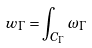<formula> <loc_0><loc_0><loc_500><loc_500>w _ { \Gamma } = \int _ { C _ { \Gamma } } \omega _ { \Gamma }</formula> 